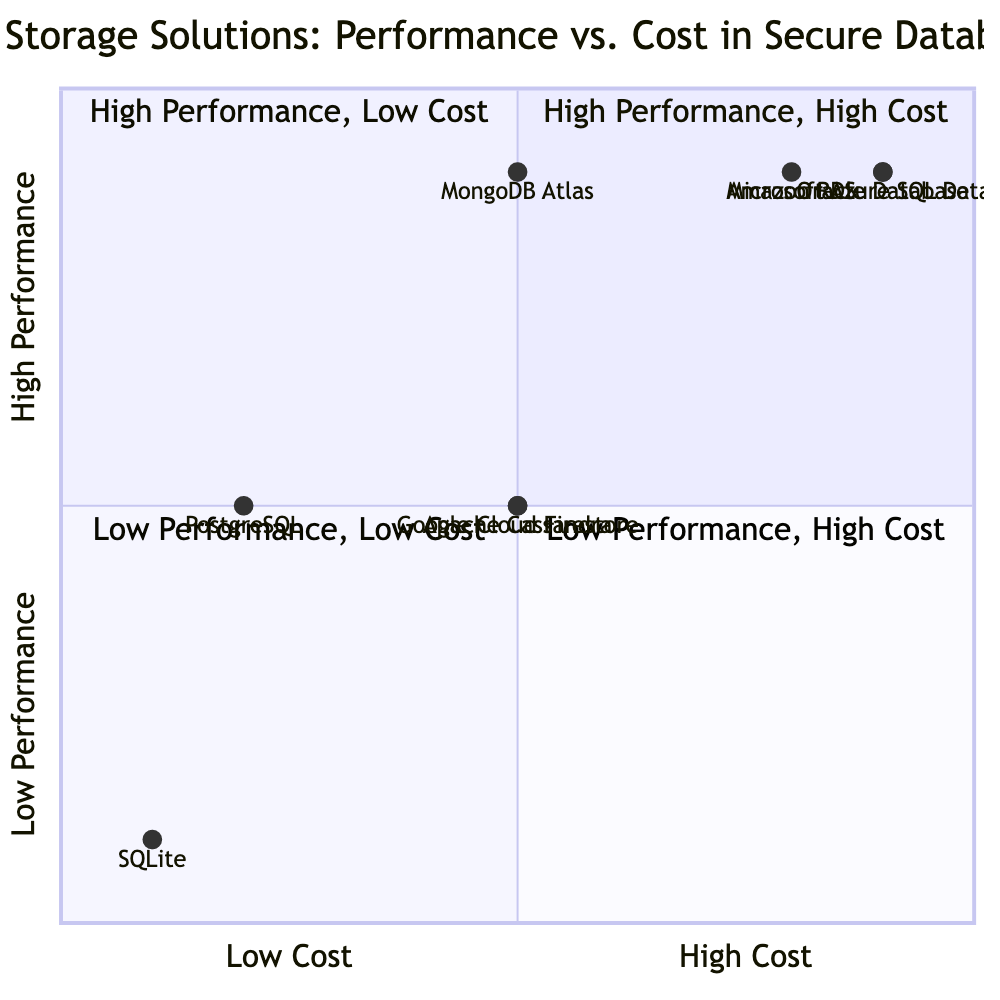What is the performance level of Amazon RDS? Amazon RDS is positioned in the quadrant for high performance, which is indicated by its vertical position near the top of the chart. The diagram categorizes it specifically as 'High' performance.
Answer: High How many data storage solutions are in the "Low Performance, Low Cost" quadrant? The "Low Performance, Low Cost" quadrant contains only one data storage solution, which is SQLite. This is confirmed by the positional data in the diagram showing SQLite located in this specific quadrant.
Answer: 1 What security feature is unique to PostgreSQL among the ones listed? PostgreSQL features "Row-Level Security," which is highlighted in its security features. This feature is not specified for any other entries in the quadrant chart, making it distinctive to PostgreSQL.
Answer: Row-Level Security Which two storage solutions have the same performance and cost? Both Google Cloud Firestore and Apache Cassandra are categorized as having 'Medium' performance and 'Medium' cost, as both sit in the center of the quadrant diagram with matching coordinates.
Answer: Google Cloud Firestore, Apache Cassandra What storage solutions fall into the "High Performance, High Cost" quadrant? The "High Performance, High Cost" quadrant contains three solutions: Amazon RDS, Microsoft Azure SQL Database, and Oracle Database. They are all positioned in this top-right quadrant.
Answer: Amazon RDS, Microsoft Azure SQL Database, Oracle Database Which database has the lowest cost? SQLite has the lowest cost, placing it in the "Low Performance, Low Cost" quadrant. Analyzing the cost attribute of all databases shows SQLite at the lowest monetary level.
Answer: Low Which data storage solution offers "Advanced Threat Protection"? Microsoft Azure SQL Database is the only solution listed that specifies "Advanced Threat Protection" in its security features, indicating its unique offering in the context of this diagram.
Answer: Microsoft Azure SQL Database What is the performance level of MongoDB Atlas? MongoDB Atlas is categorized in the quadrant for high performance, indicated by its vertical position near the top. Within the diagram, it is explicitly marked as 'High' performance.
Answer: High 